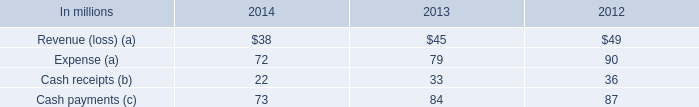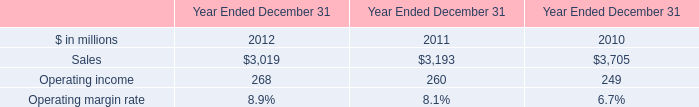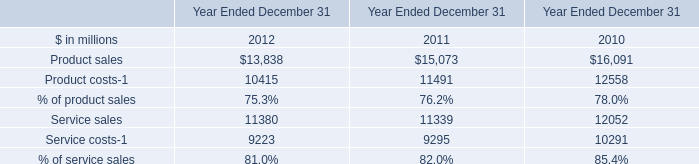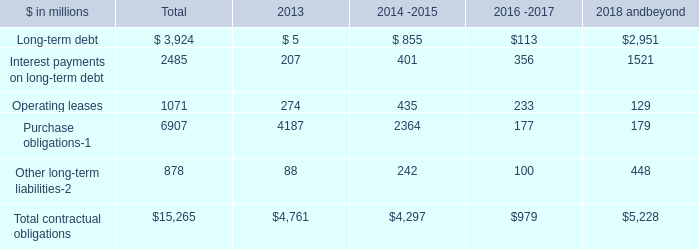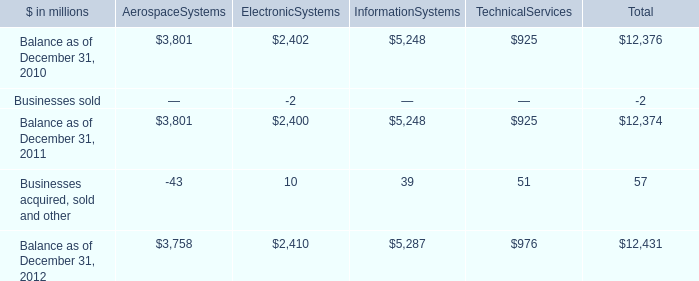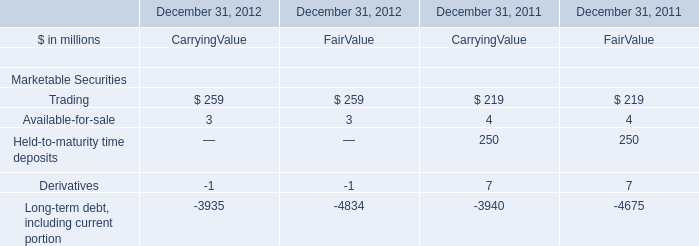What's the total amount of the CarryingValue in the year where Held-to-maturity time deposits greater than 0? (in million) 
Computations: ((((219 + 250) + 4) + 7) - 3940)
Answer: -3460.0. 